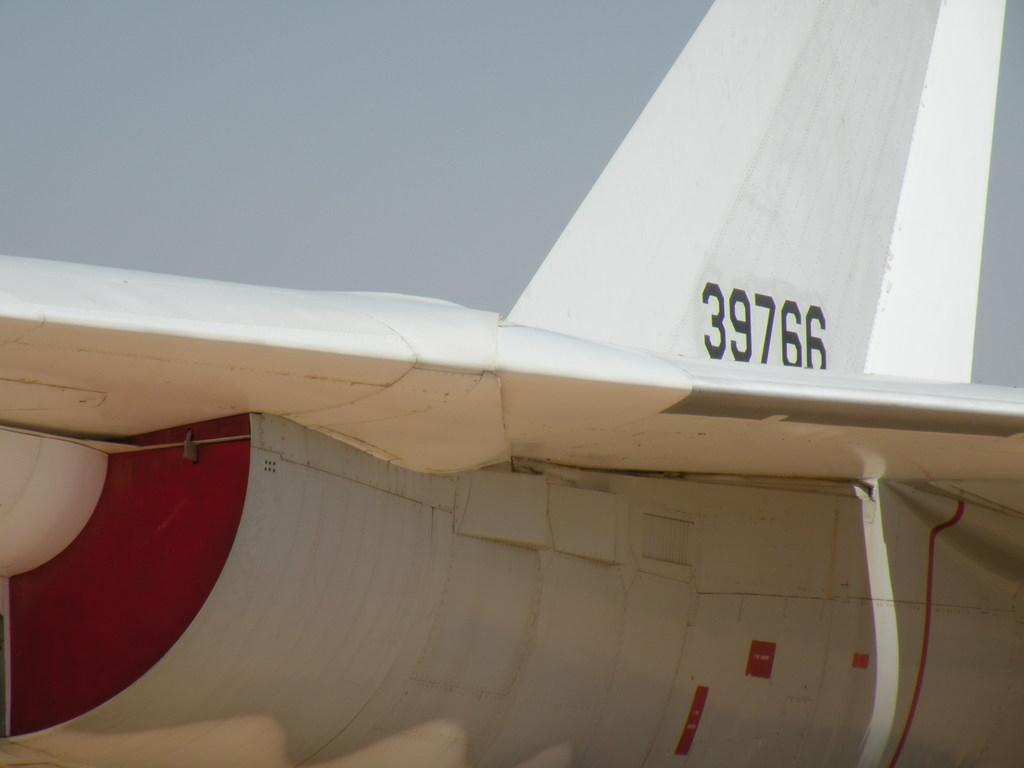What is the main subject of the image? The main subject of the image is an aeroplane. What can be seen in the background of the image? There is sky visible in the background of the image. How many spiders are crawling on the wings of the aeroplane in the image? There are no spiders present on the aeroplane in the image. What type of twist is depicted in the image? There is no twist depicted in the image; it features an aeroplane and sky. 